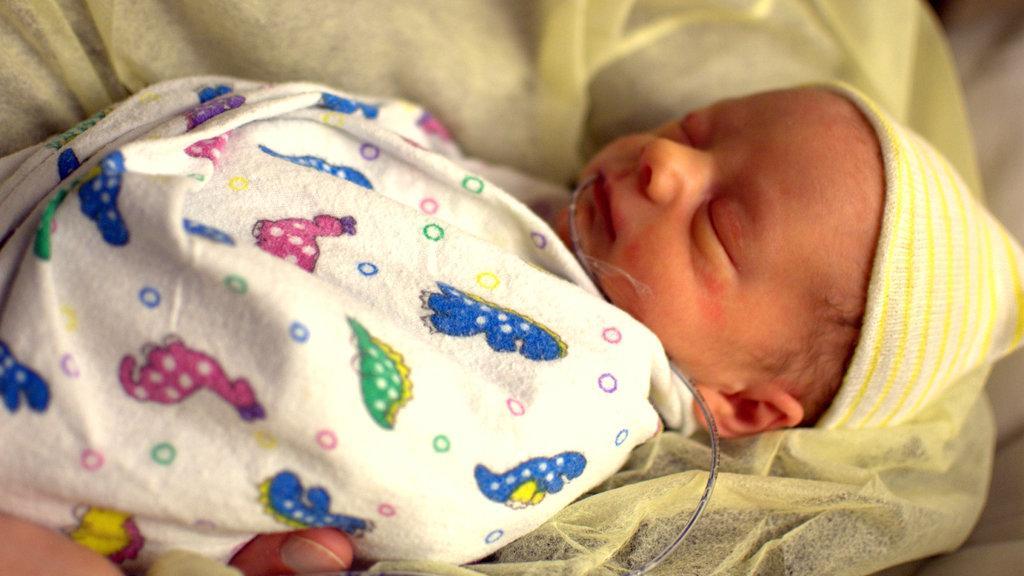Can you describe this image briefly? In the foreground of this image, there is a baby and we can also see a pipe in her mouth is carrying by a person. 